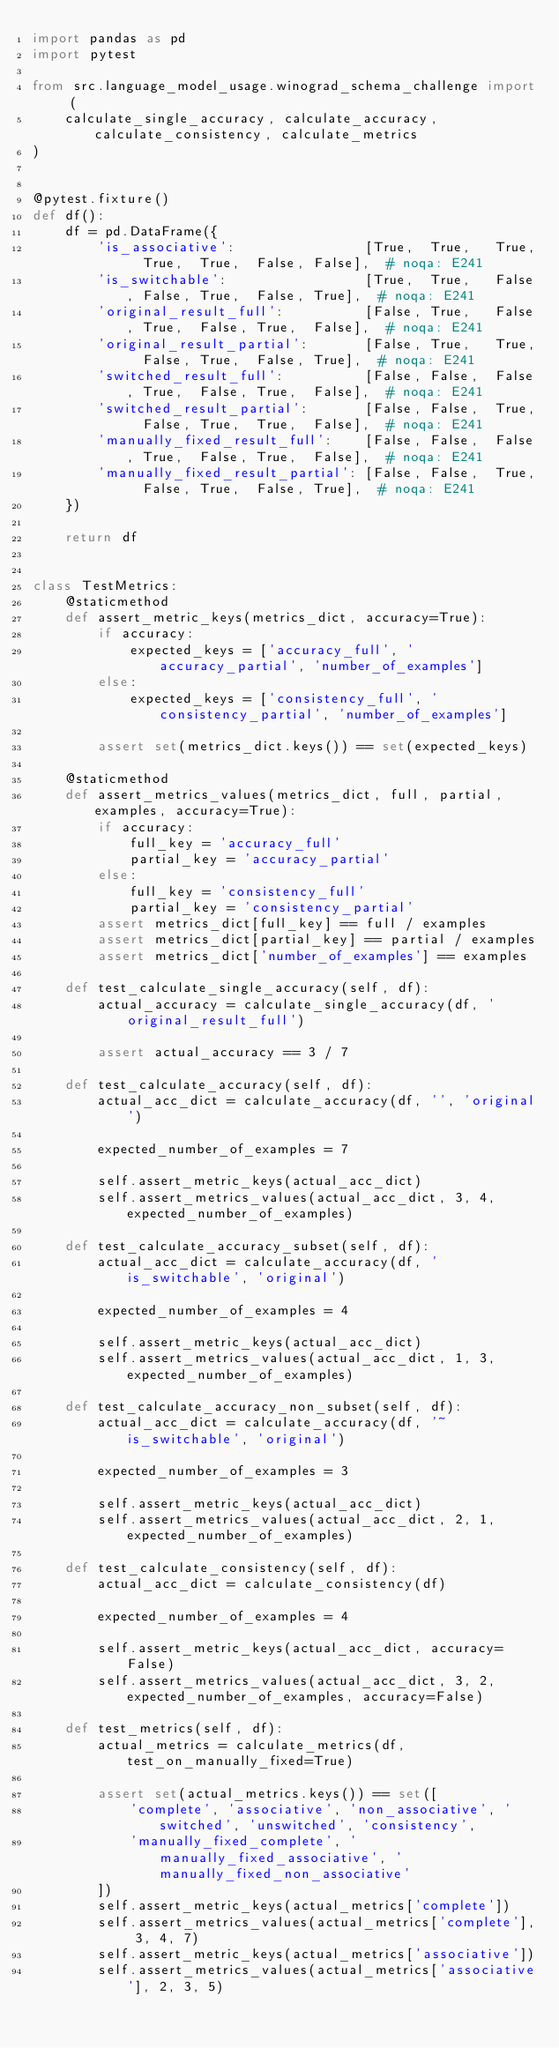Convert code to text. <code><loc_0><loc_0><loc_500><loc_500><_Python_>import pandas as pd
import pytest

from src.language_model_usage.winograd_schema_challenge import (
    calculate_single_accuracy, calculate_accuracy, calculate_consistency, calculate_metrics
)


@pytest.fixture()
def df():
    df = pd.DataFrame({
        'is_associative':                [True,  True,   True,  True,  True,  False, False],  # noqa: E241
        'is_switchable':                 [True,  True,   False, False, True,  False, True],  # noqa: E241
        'original_result_full':          [False, True,   False, True,  False, True,  False],  # noqa: E241
        'original_result_partial':       [False, True,   True,  False, True,  False, True],  # noqa: E241
        'switched_result_full':          [False, False,  False, True,  False, True,  False],  # noqa: E241
        'switched_result_partial':       [False, False,  True,  False, True,  True,  False],  # noqa: E241
        'manually_fixed_result_full':    [False, False,  False, True,  False, True,  False],  # noqa: E241
        'manually_fixed_result_partial': [False, False,  True,  False, True,  False, True],  # noqa: E241
    })

    return df


class TestMetrics:
    @staticmethod
    def assert_metric_keys(metrics_dict, accuracy=True):
        if accuracy:
            expected_keys = ['accuracy_full', 'accuracy_partial', 'number_of_examples']
        else:
            expected_keys = ['consistency_full', 'consistency_partial', 'number_of_examples']

        assert set(metrics_dict.keys()) == set(expected_keys)

    @staticmethod
    def assert_metrics_values(metrics_dict, full, partial, examples, accuracy=True):
        if accuracy:
            full_key = 'accuracy_full'
            partial_key = 'accuracy_partial'
        else:
            full_key = 'consistency_full'
            partial_key = 'consistency_partial'
        assert metrics_dict[full_key] == full / examples
        assert metrics_dict[partial_key] == partial / examples
        assert metrics_dict['number_of_examples'] == examples

    def test_calculate_single_accuracy(self, df):
        actual_accuracy = calculate_single_accuracy(df, 'original_result_full')

        assert actual_accuracy == 3 / 7

    def test_calculate_accuracy(self, df):
        actual_acc_dict = calculate_accuracy(df, '', 'original')

        expected_number_of_examples = 7

        self.assert_metric_keys(actual_acc_dict)
        self.assert_metrics_values(actual_acc_dict, 3, 4, expected_number_of_examples)

    def test_calculate_accuracy_subset(self, df):
        actual_acc_dict = calculate_accuracy(df, 'is_switchable', 'original')

        expected_number_of_examples = 4

        self.assert_metric_keys(actual_acc_dict)
        self.assert_metrics_values(actual_acc_dict, 1, 3, expected_number_of_examples)

    def test_calculate_accuracy_non_subset(self, df):
        actual_acc_dict = calculate_accuracy(df, '~is_switchable', 'original')

        expected_number_of_examples = 3

        self.assert_metric_keys(actual_acc_dict)
        self.assert_metrics_values(actual_acc_dict, 2, 1, expected_number_of_examples)

    def test_calculate_consistency(self, df):
        actual_acc_dict = calculate_consistency(df)

        expected_number_of_examples = 4

        self.assert_metric_keys(actual_acc_dict, accuracy=False)
        self.assert_metrics_values(actual_acc_dict, 3, 2, expected_number_of_examples, accuracy=False)

    def test_metrics(self, df):
        actual_metrics = calculate_metrics(df, test_on_manually_fixed=True)

        assert set(actual_metrics.keys()) == set([
            'complete', 'associative', 'non_associative', 'switched', 'unswitched', 'consistency',
            'manually_fixed_complete', 'manually_fixed_associative', 'manually_fixed_non_associative'
        ])
        self.assert_metric_keys(actual_metrics['complete'])
        self.assert_metrics_values(actual_metrics['complete'], 3, 4, 7)
        self.assert_metric_keys(actual_metrics['associative'])
        self.assert_metrics_values(actual_metrics['associative'], 2, 3, 5)</code> 